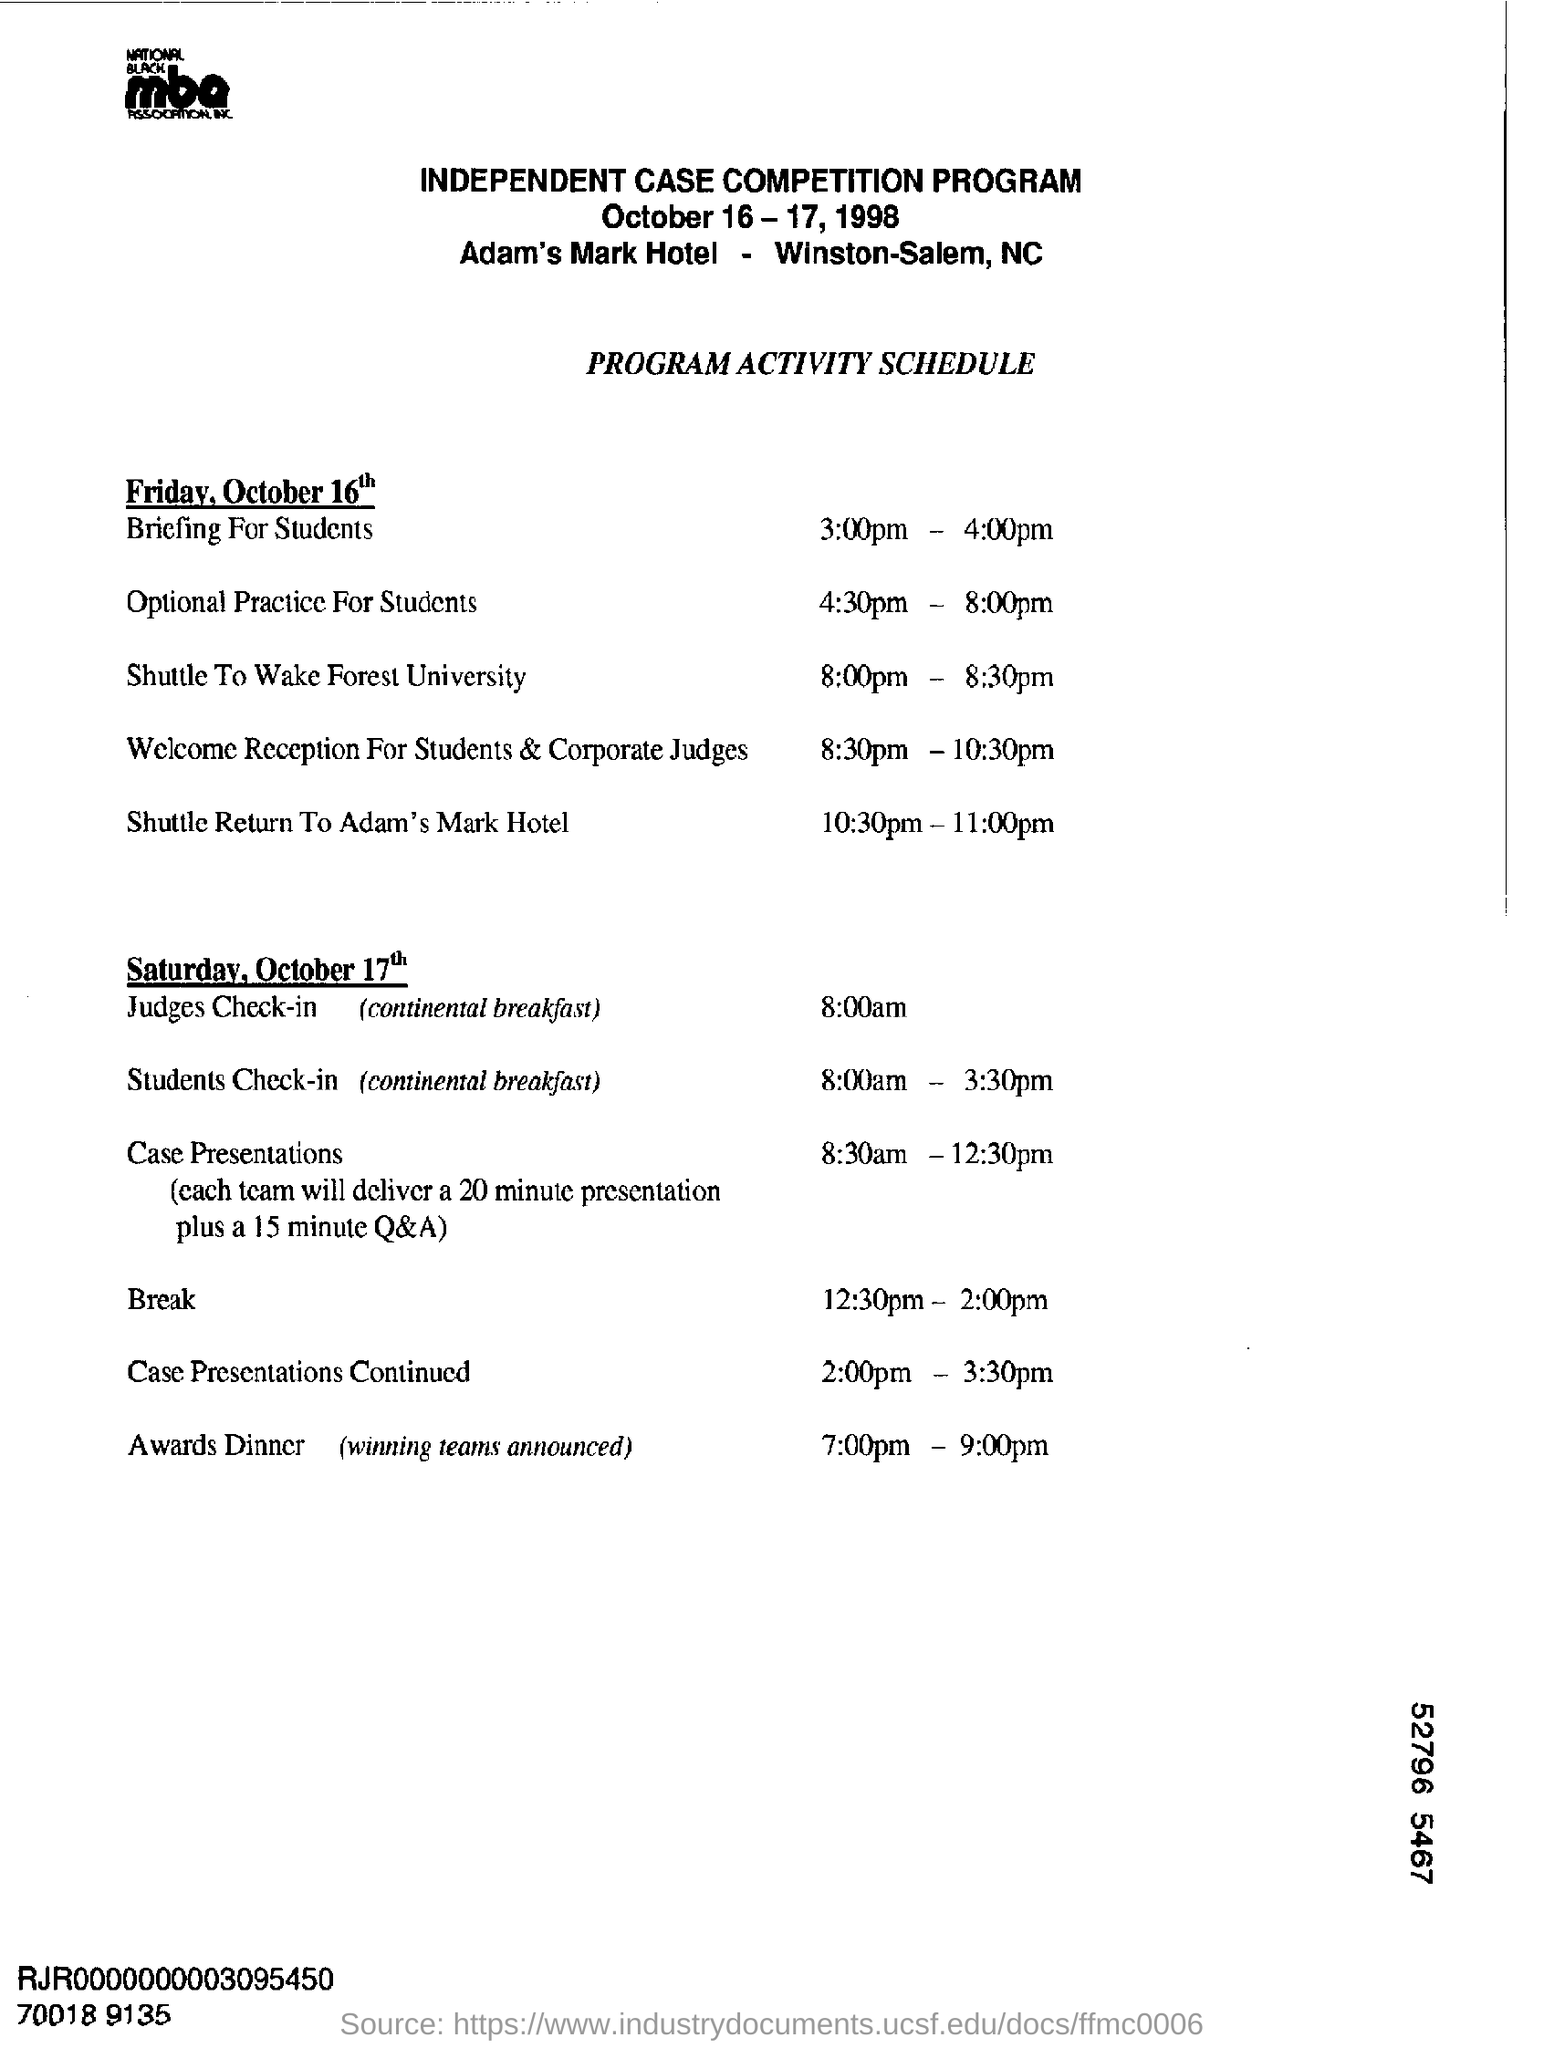List a handful of essential elements in this visual. The Adam's Mark Hotel was the location where an independent case competition program was held. On the day of Saturday, October 17th, case presentations will be held. The name of the competition program is INDEPENDENT CASE. 